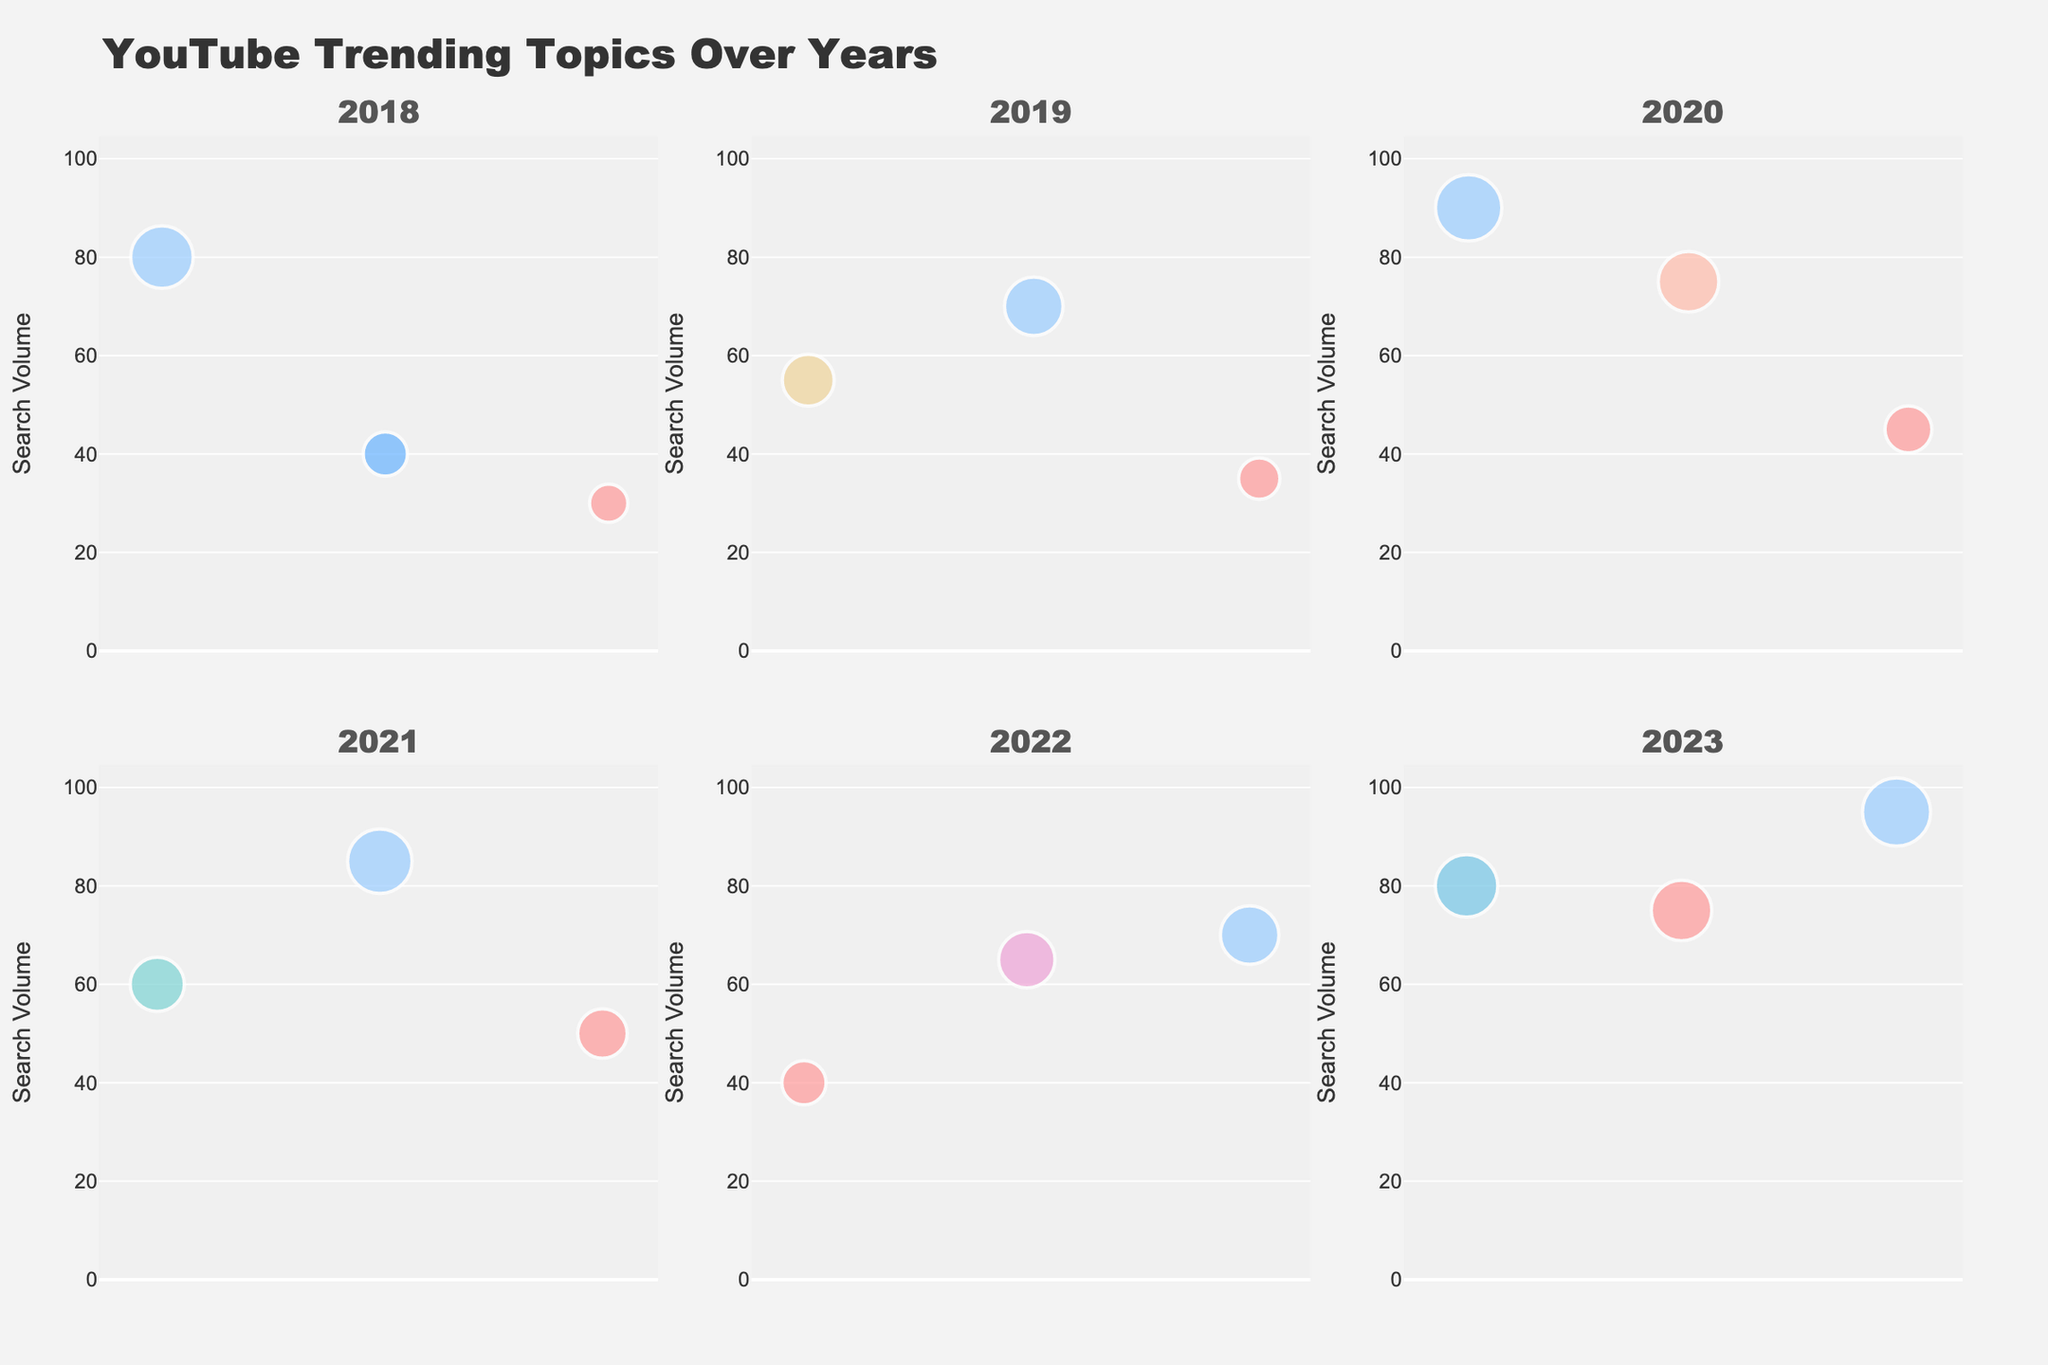What's the title of the plot? The title is typically placed at the top of the plot and serves as a summary of the visual content. In this case, the title should be easily observable.
Answer: YouTube Trending Topics Over Years Which year had the highest search volume for a single topic? To find this, look for the largest bubble across all subplots. The biggest bubble represents the highest search volume. The 2023 subplot contains the largest bubble for the 'Taylor Swift Eras Tour' with a search volume of 95.
Answer: 2023 How does the search volume for “Fortnite” in 2018 compare to “AI Art” in 2023? To compare, locate the bubbles for "Fortnite" in 2018 and "AI Art" in 2023 and compare their sizes. "Fortnite" in 2018 has a search volume of 80, while "AI Art" in 2023 has the same search volume of 80.
Answer: Both are equal What is the average search volume for topics in 2020? Add the search volumes for "Quarantine Life" (90), "Home Workouts" (75), and "Sourdough Bread" (45), then divide by the number of topics (3). The calculation is (90 + 75 + 45)/3 = 70.
Answer: 70 Is the search volume of "Squid Game" in 2021 greater than the search volume of "Fortnite" in 2018? Locate the bubbles for "Squid Game" in 2021 and "Fortnite" in 2018 and compare their sizes. "Squid Game" has a search volume of 85, which is greater than "Fortnite" with 80.
Answer: Yes Which two topics had the same search volume but appeared in different years? Identify bubbles of the same size representing the same search volume in different subplots (years). "Fortnite" in 2018 and "AI Art" in 2023 both have a search volume of 80.
Answer: Fortnite (2018) and AI Art (2023) How many topics had a search volume greater than 50 in 2022? Count the bubbles in the 2022 subplot with a search volume greater than 50. "Johnny Depp Trial" (65) and "Ukraine Conflict" (70) are the ones that meet this criterion. There are 2 such topics.
Answer: 2 What is the total search volume for all topics in 2019? Sum the search volumes for all topics in the 2019 subplot: "ASMR" (55), "TikTok Challenges" (70), and "Mukbang" (35). The calculation is 55 + 70 + 35 = 160.
Answer: 160 Which topic had the smallest search volume in 2021? Identify the smallest bubble in the 2021 subplot. "True Crime" has the smallest search volume of 50.
Answer: True Crime What's the incremental difference in search volume between "Squid Game" and "NFTs" in 2021? Subtract the search volume of "NFTs" from "Squid Game" in 2021: 85 - 60 = 25.
Answer: 25 